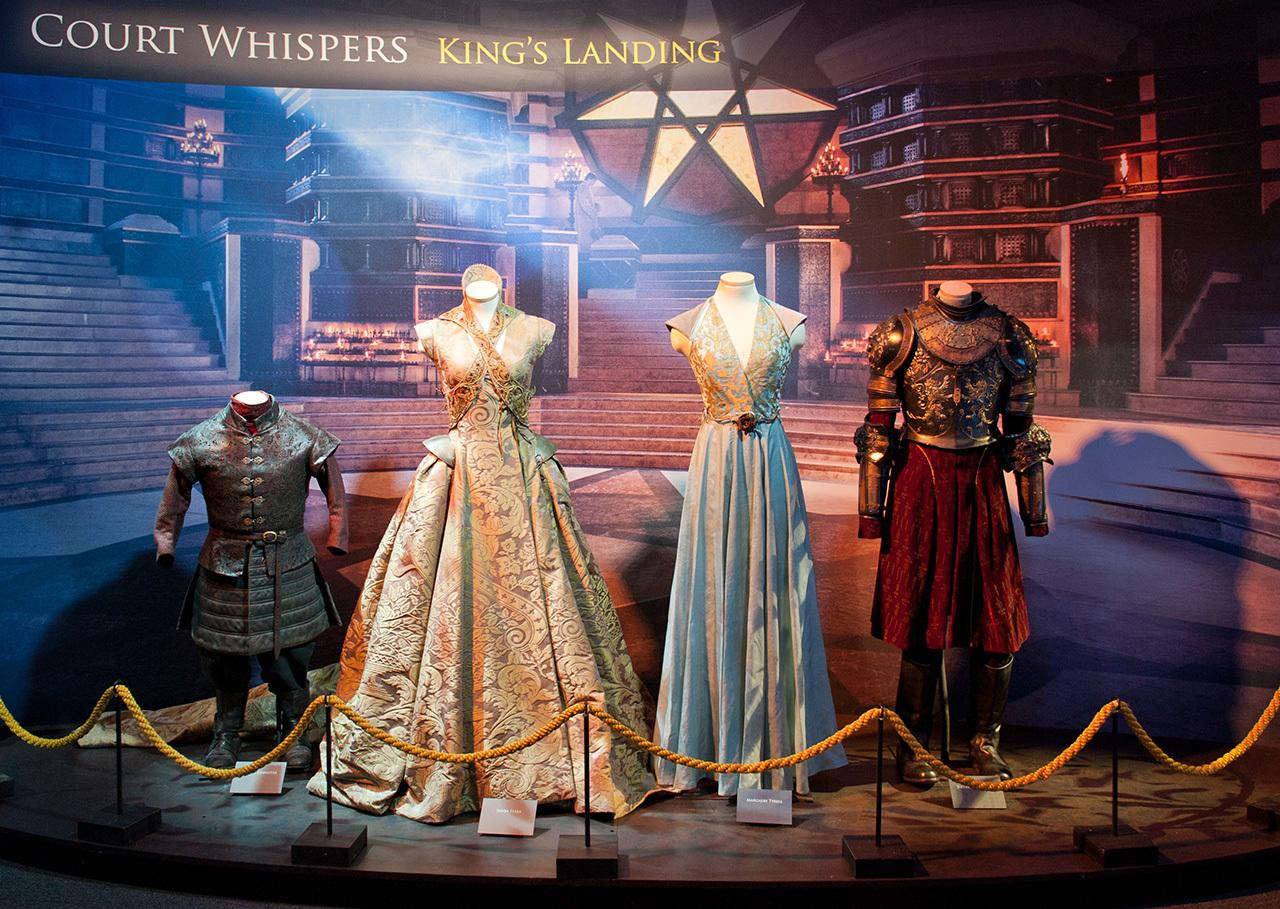What type of materials and techniques might have been used to create these costumes? The costumes displayed likely utilize a combination of luxurious fabrics such as silk, velvet, and brocade. Techniques such as embroidery, beadwork, and goldsmithing are evident, emphasizing the regal and intricate designs suitable for high-status individuals in a royal court setting. The detailing and texture suggest a meticulous attention to historical accuracy and artistic embellishment. 